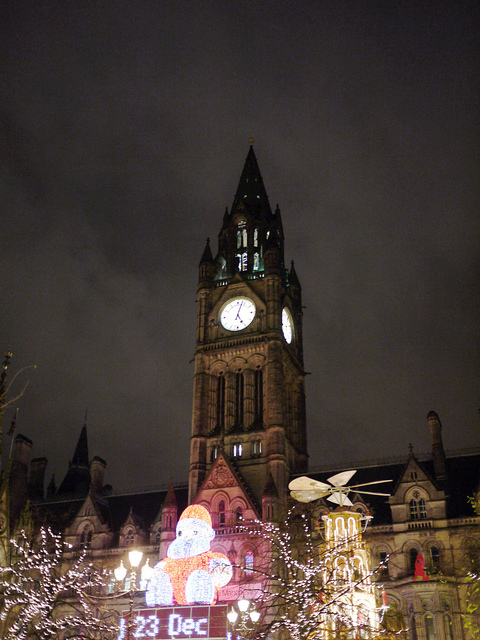Extract all visible text content from this image. 23 Dec 